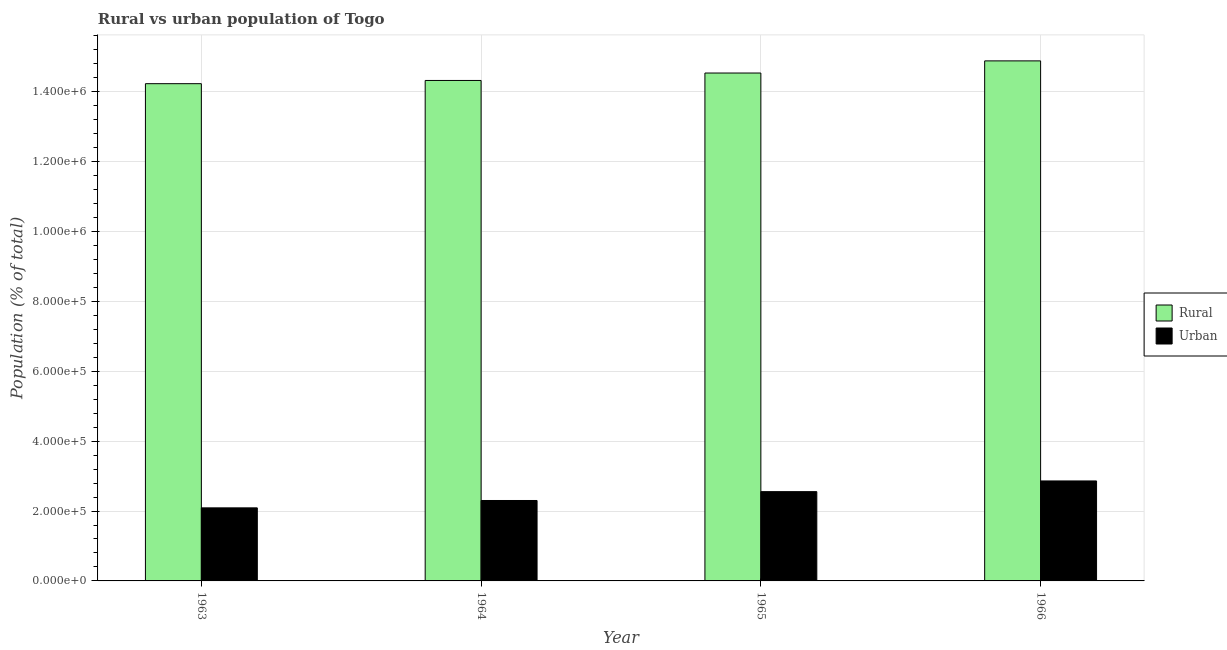How many different coloured bars are there?
Offer a very short reply. 2. How many groups of bars are there?
Your response must be concise. 4. How many bars are there on the 3rd tick from the left?
Your answer should be very brief. 2. What is the rural population density in 1966?
Provide a short and direct response. 1.49e+06. Across all years, what is the maximum urban population density?
Provide a short and direct response. 2.86e+05. Across all years, what is the minimum rural population density?
Provide a succinct answer. 1.42e+06. In which year was the urban population density maximum?
Keep it short and to the point. 1966. In which year was the rural population density minimum?
Provide a succinct answer. 1963. What is the total urban population density in the graph?
Your response must be concise. 9.81e+05. What is the difference between the rural population density in 1964 and that in 1965?
Offer a very short reply. -2.13e+04. What is the difference between the urban population density in 1963 and the rural population density in 1965?
Offer a very short reply. -4.64e+04. What is the average urban population density per year?
Your response must be concise. 2.45e+05. In the year 1965, what is the difference between the rural population density and urban population density?
Provide a succinct answer. 0. In how many years, is the urban population density greater than 400000 %?
Your answer should be very brief. 0. What is the ratio of the rural population density in 1963 to that in 1966?
Offer a terse response. 0.96. Is the rural population density in 1964 less than that in 1965?
Give a very brief answer. Yes. What is the difference between the highest and the second highest rural population density?
Give a very brief answer. 3.48e+04. What is the difference between the highest and the lowest urban population density?
Offer a terse response. 7.70e+04. In how many years, is the rural population density greater than the average rural population density taken over all years?
Keep it short and to the point. 2. Is the sum of the urban population density in 1965 and 1966 greater than the maximum rural population density across all years?
Your response must be concise. Yes. What does the 1st bar from the left in 1964 represents?
Give a very brief answer. Rural. What does the 1st bar from the right in 1966 represents?
Your response must be concise. Urban. Are all the bars in the graph horizontal?
Give a very brief answer. No. How many years are there in the graph?
Your response must be concise. 4. Does the graph contain any zero values?
Give a very brief answer. No. How many legend labels are there?
Ensure brevity in your answer.  2. How are the legend labels stacked?
Your answer should be very brief. Vertical. What is the title of the graph?
Offer a very short reply. Rural vs urban population of Togo. Does "Private funds" appear as one of the legend labels in the graph?
Give a very brief answer. No. What is the label or title of the Y-axis?
Provide a succinct answer. Population (% of total). What is the Population (% of total) in Rural in 1963?
Your answer should be very brief. 1.42e+06. What is the Population (% of total) of Urban in 1963?
Ensure brevity in your answer.  2.09e+05. What is the Population (% of total) in Rural in 1964?
Keep it short and to the point. 1.43e+06. What is the Population (% of total) of Urban in 1964?
Offer a terse response. 2.30e+05. What is the Population (% of total) in Rural in 1965?
Provide a succinct answer. 1.45e+06. What is the Population (% of total) of Urban in 1965?
Keep it short and to the point. 2.55e+05. What is the Population (% of total) in Rural in 1966?
Offer a terse response. 1.49e+06. What is the Population (% of total) of Urban in 1966?
Offer a terse response. 2.86e+05. Across all years, what is the maximum Population (% of total) in Rural?
Give a very brief answer. 1.49e+06. Across all years, what is the maximum Population (% of total) of Urban?
Your response must be concise. 2.86e+05. Across all years, what is the minimum Population (% of total) of Rural?
Offer a very short reply. 1.42e+06. Across all years, what is the minimum Population (% of total) of Urban?
Your answer should be compact. 2.09e+05. What is the total Population (% of total) of Rural in the graph?
Ensure brevity in your answer.  5.80e+06. What is the total Population (% of total) in Urban in the graph?
Provide a succinct answer. 9.81e+05. What is the difference between the Population (% of total) of Rural in 1963 and that in 1964?
Give a very brief answer. -9207. What is the difference between the Population (% of total) of Urban in 1963 and that in 1964?
Make the answer very short. -2.11e+04. What is the difference between the Population (% of total) of Rural in 1963 and that in 1965?
Keep it short and to the point. -3.05e+04. What is the difference between the Population (% of total) of Urban in 1963 and that in 1965?
Keep it short and to the point. -4.64e+04. What is the difference between the Population (% of total) of Rural in 1963 and that in 1966?
Keep it short and to the point. -6.52e+04. What is the difference between the Population (% of total) in Urban in 1963 and that in 1966?
Offer a very short reply. -7.70e+04. What is the difference between the Population (% of total) of Rural in 1964 and that in 1965?
Ensure brevity in your answer.  -2.13e+04. What is the difference between the Population (% of total) of Urban in 1964 and that in 1965?
Make the answer very short. -2.53e+04. What is the difference between the Population (% of total) of Rural in 1964 and that in 1966?
Provide a succinct answer. -5.60e+04. What is the difference between the Population (% of total) of Urban in 1964 and that in 1966?
Offer a very short reply. -5.59e+04. What is the difference between the Population (% of total) in Rural in 1965 and that in 1966?
Keep it short and to the point. -3.48e+04. What is the difference between the Population (% of total) of Urban in 1965 and that in 1966?
Your answer should be very brief. -3.06e+04. What is the difference between the Population (% of total) in Rural in 1963 and the Population (% of total) in Urban in 1964?
Your answer should be very brief. 1.19e+06. What is the difference between the Population (% of total) of Rural in 1963 and the Population (% of total) of Urban in 1965?
Give a very brief answer. 1.17e+06. What is the difference between the Population (% of total) in Rural in 1963 and the Population (% of total) in Urban in 1966?
Provide a short and direct response. 1.14e+06. What is the difference between the Population (% of total) in Rural in 1964 and the Population (% of total) in Urban in 1965?
Ensure brevity in your answer.  1.18e+06. What is the difference between the Population (% of total) in Rural in 1964 and the Population (% of total) in Urban in 1966?
Your answer should be compact. 1.15e+06. What is the difference between the Population (% of total) of Rural in 1965 and the Population (% of total) of Urban in 1966?
Keep it short and to the point. 1.17e+06. What is the average Population (% of total) of Rural per year?
Offer a very short reply. 1.45e+06. What is the average Population (% of total) in Urban per year?
Your answer should be very brief. 2.45e+05. In the year 1963, what is the difference between the Population (% of total) of Rural and Population (% of total) of Urban?
Your answer should be very brief. 1.21e+06. In the year 1964, what is the difference between the Population (% of total) of Rural and Population (% of total) of Urban?
Provide a short and direct response. 1.20e+06. In the year 1965, what is the difference between the Population (% of total) of Rural and Population (% of total) of Urban?
Provide a short and direct response. 1.20e+06. In the year 1966, what is the difference between the Population (% of total) in Rural and Population (% of total) in Urban?
Offer a terse response. 1.20e+06. What is the ratio of the Population (% of total) in Urban in 1963 to that in 1964?
Provide a short and direct response. 0.91. What is the ratio of the Population (% of total) of Urban in 1963 to that in 1965?
Your answer should be compact. 0.82. What is the ratio of the Population (% of total) in Rural in 1963 to that in 1966?
Your answer should be very brief. 0.96. What is the ratio of the Population (% of total) in Urban in 1963 to that in 1966?
Make the answer very short. 0.73. What is the ratio of the Population (% of total) of Rural in 1964 to that in 1965?
Ensure brevity in your answer.  0.99. What is the ratio of the Population (% of total) in Urban in 1964 to that in 1965?
Your answer should be compact. 0.9. What is the ratio of the Population (% of total) of Rural in 1964 to that in 1966?
Keep it short and to the point. 0.96. What is the ratio of the Population (% of total) of Urban in 1964 to that in 1966?
Your response must be concise. 0.8. What is the ratio of the Population (% of total) of Rural in 1965 to that in 1966?
Offer a terse response. 0.98. What is the ratio of the Population (% of total) of Urban in 1965 to that in 1966?
Provide a short and direct response. 0.89. What is the difference between the highest and the second highest Population (% of total) of Rural?
Your answer should be very brief. 3.48e+04. What is the difference between the highest and the second highest Population (% of total) of Urban?
Keep it short and to the point. 3.06e+04. What is the difference between the highest and the lowest Population (% of total) of Rural?
Your answer should be very brief. 6.52e+04. What is the difference between the highest and the lowest Population (% of total) in Urban?
Your answer should be very brief. 7.70e+04. 